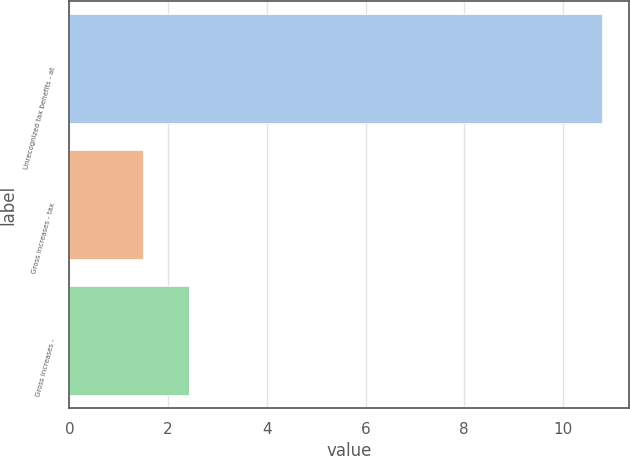Convert chart. <chart><loc_0><loc_0><loc_500><loc_500><bar_chart><fcel>Unrecognized tax benefits - at<fcel>Gross increases - tax<fcel>Gross increases -<nl><fcel>10.8<fcel>1.5<fcel>2.43<nl></chart> 